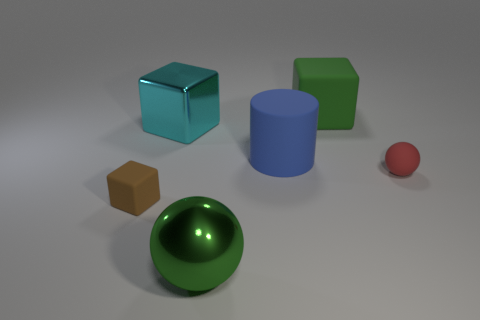What number of objects are either metal objects that are behind the red matte thing or green objects behind the green sphere?
Offer a terse response. 2. Do the blue rubber cylinder that is in front of the green matte cube and the rubber cube in front of the cyan object have the same size?
Provide a short and direct response. No. What is the color of the small matte thing that is the same shape as the green shiny object?
Offer a terse response. Red. Is there anything else that has the same shape as the large cyan thing?
Ensure brevity in your answer.  Yes. Are there more cubes in front of the tiny matte sphere than tiny red spheres on the left side of the large shiny block?
Offer a very short reply. Yes. There is a shiny thing that is to the right of the big block that is left of the cube to the right of the large blue thing; what size is it?
Your answer should be very brief. Large. Is the material of the large cyan thing the same as the big green thing on the right side of the green ball?
Give a very brief answer. No. Does the brown thing have the same shape as the big cyan metal thing?
Your response must be concise. Yes. What number of other things are the same material as the blue thing?
Your answer should be very brief. 3. How many tiny things have the same shape as the large cyan object?
Your answer should be compact. 1. 